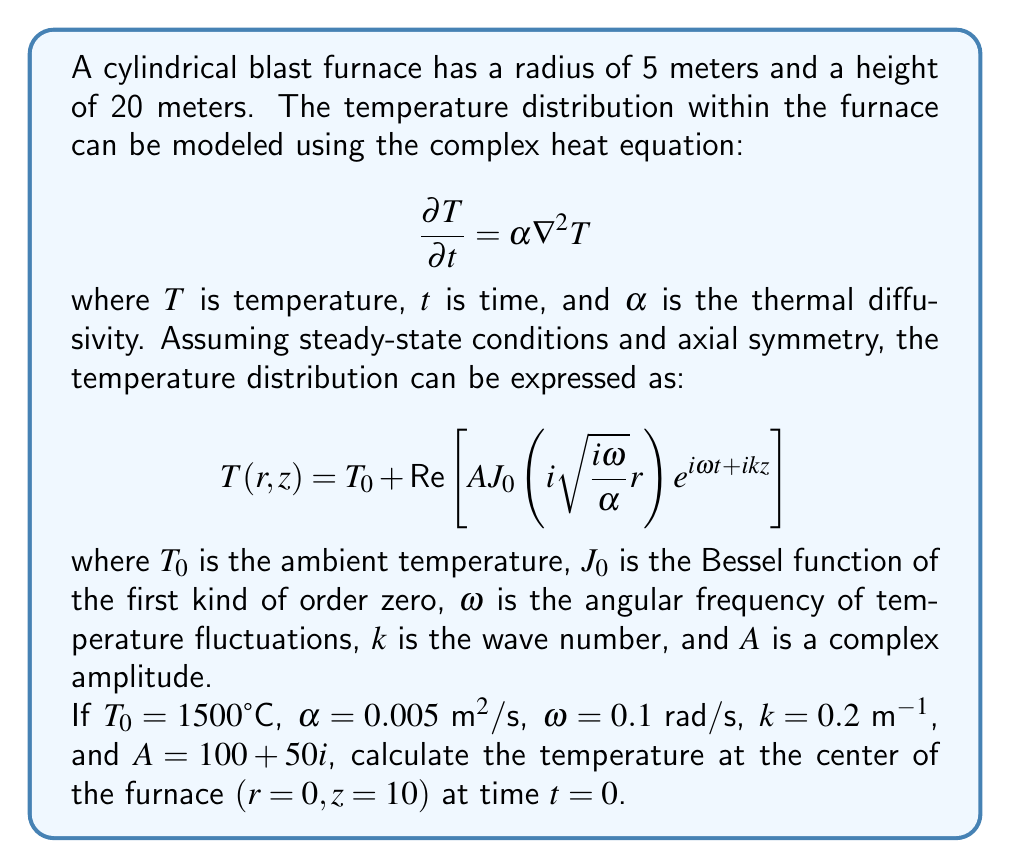Show me your answer to this math problem. To solve this problem, we need to follow these steps:

1) First, we need to evaluate the Bessel function at $r=0$. The Bessel function of the first kind of order zero at zero is always 1:

   $J_0(0) = 1$

2) Now, let's calculate the argument of the Bessel function:

   $$i\sqrt{\frac{i\omega}{\alpha}}r = i\sqrt{\frac{i(0.1)}{0.005}}(0) = 0$$

3) At $z=10$ and $t=0$, the exponential term becomes:

   $e^{i\omega t + ikz} = e^{i(0.1)(0) + i(0.2)(10)} = e^{2i} = \cos(2) + i\sin(2)$

4) Now we can write out the full equation:

   $T(0,10) = 1500 + \text{Re}\left[(100+50i)(1)(e^{2i})\right]$

5) Let's multiply the complex numbers:

   $(100+50i)(\cos(2) + i\sin(2)) = (100\cos(2) - 50\sin(2)) + i(100\sin(2) + 50\cos(2))$

6) We only need the real part:

   $\text{Re}\left[(100+50i)(e^{2i})\right] = 100\cos(2) - 50\sin(2)$

7) Calculate the values:

   $100\cos(2) - 50\sin(2) \approx -41.61$

8) Finally, add this to the ambient temperature:

   $T(0,10) = 1500 + (-41.61) = 1458.39°C$
Answer: 1458.39°C 